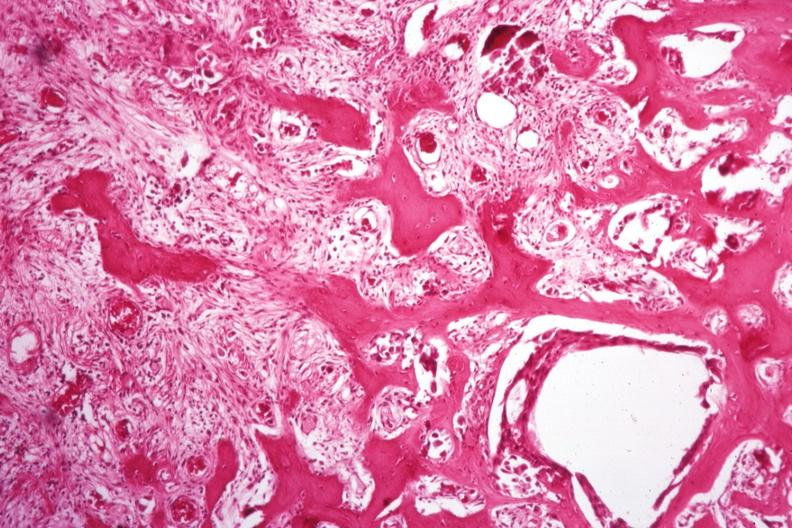s this image shows wrights typical present?
Answer the question using a single word or phrase. No 